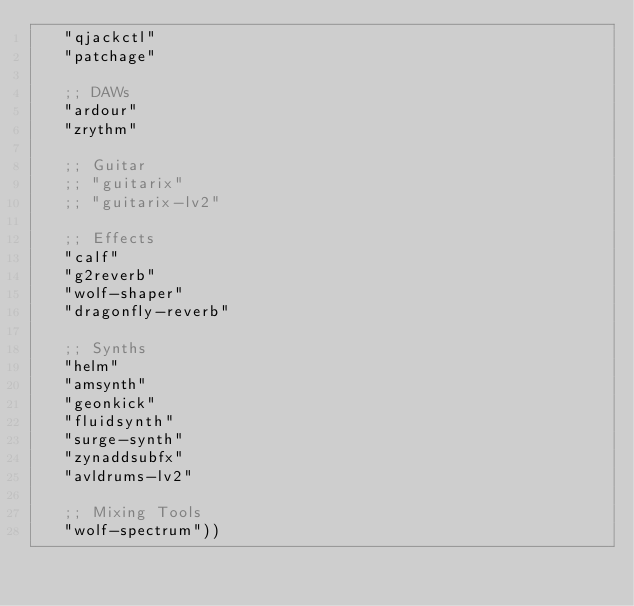Convert code to text. <code><loc_0><loc_0><loc_500><loc_500><_Scheme_>   "qjackctl"
   "patchage"

   ;; DAWs
   "ardour"
   "zrythm"

   ;; Guitar
   ;; "guitarix"
   ;; "guitarix-lv2"

   ;; Effects
   "calf"
   "g2reverb"
   "wolf-shaper"
   "dragonfly-reverb"

   ;; Synths
   "helm"
   "amsynth"
   "geonkick"
   "fluidsynth"
   "surge-synth"
   "zynaddsubfx"
   "avldrums-lv2"

   ;; Mixing Tools
   "wolf-spectrum"))
</code> 